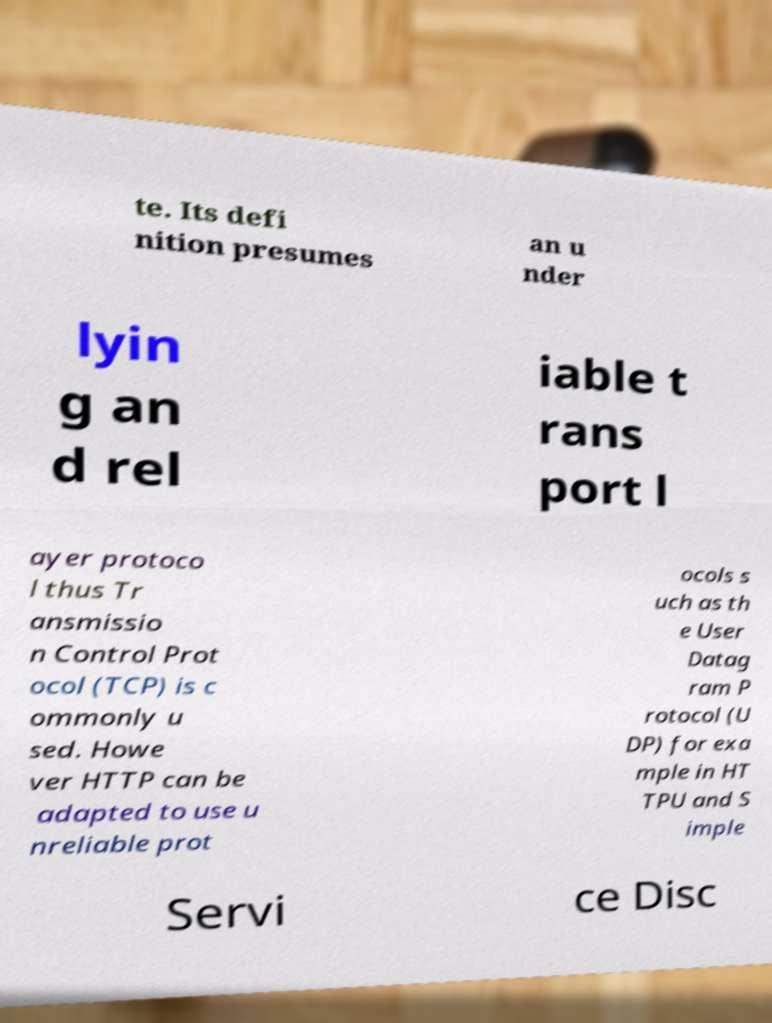What messages or text are displayed in this image? I need them in a readable, typed format. te. Its defi nition presumes an u nder lyin g an d rel iable t rans port l ayer protoco l thus Tr ansmissio n Control Prot ocol (TCP) is c ommonly u sed. Howe ver HTTP can be adapted to use u nreliable prot ocols s uch as th e User Datag ram P rotocol (U DP) for exa mple in HT TPU and S imple Servi ce Disc 